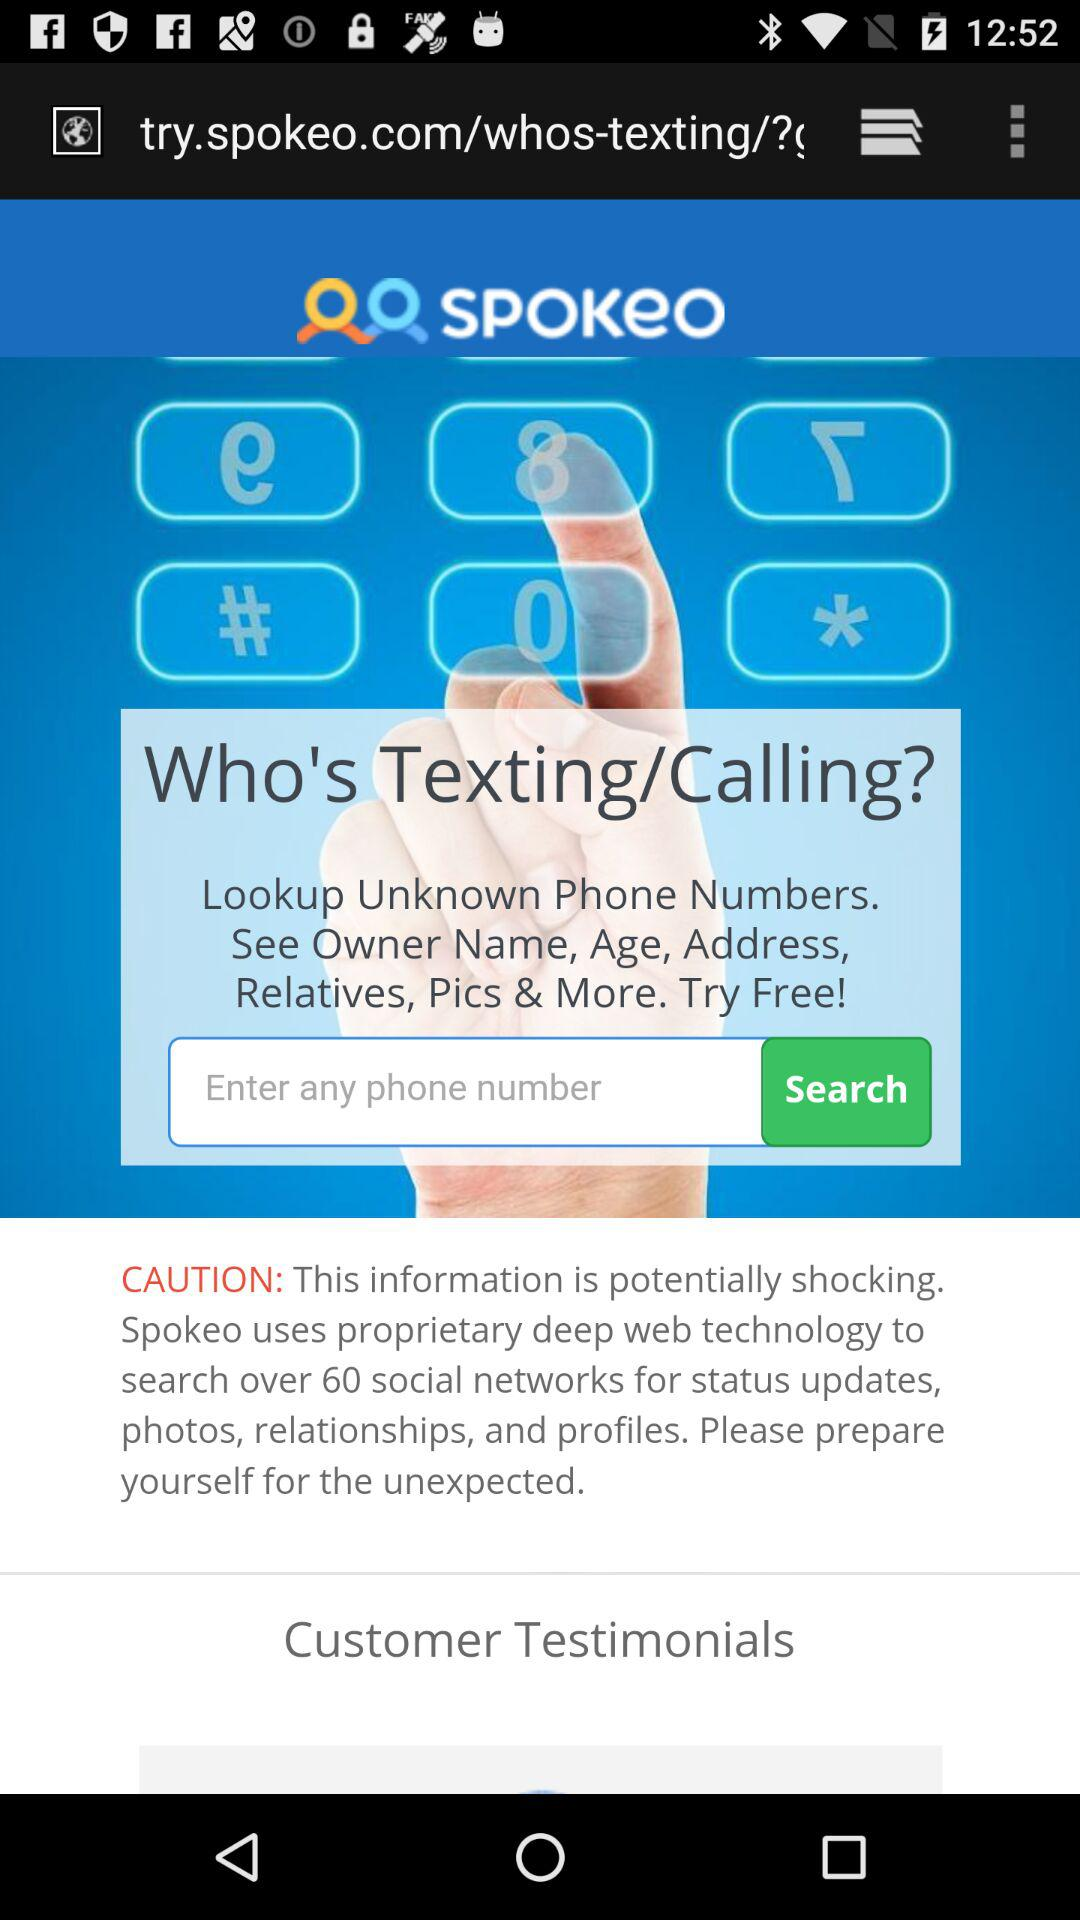What is the application name? The application name is "SPOKeO". 